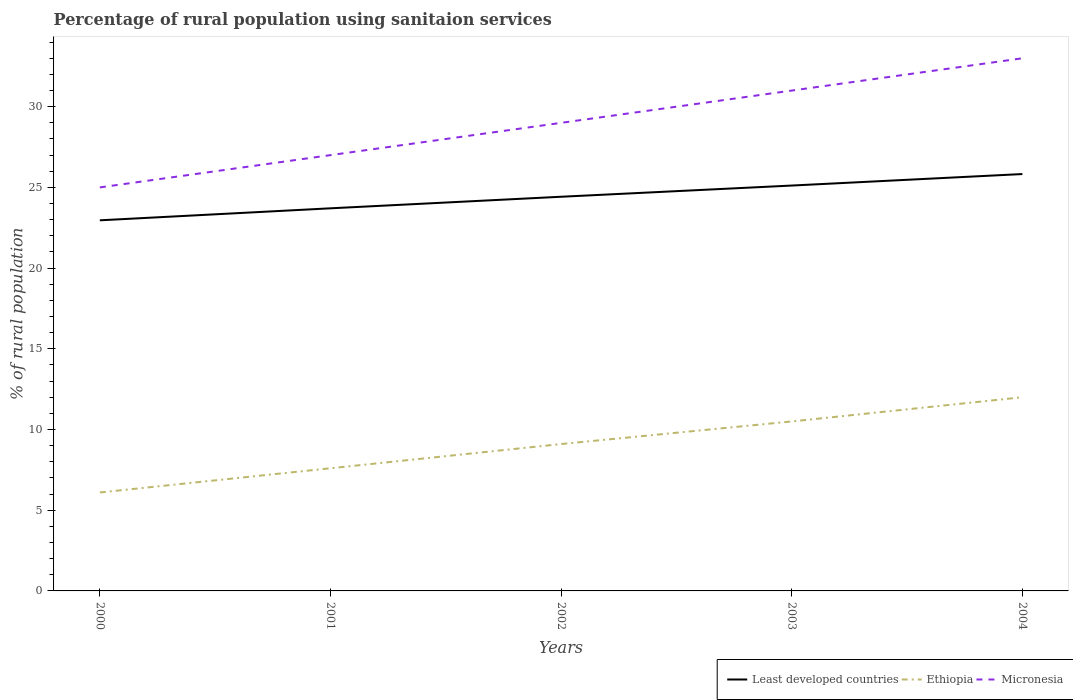Does the line corresponding to Least developed countries intersect with the line corresponding to Micronesia?
Give a very brief answer. No. Across all years, what is the maximum percentage of rural population using sanitaion services in Least developed countries?
Your response must be concise. 22.96. In which year was the percentage of rural population using sanitaion services in Ethiopia maximum?
Offer a very short reply. 2000. What is the total percentage of rural population using sanitaion services in Micronesia in the graph?
Ensure brevity in your answer.  -8. What is the difference between the highest and the second highest percentage of rural population using sanitaion services in Micronesia?
Ensure brevity in your answer.  8. What is the difference between the highest and the lowest percentage of rural population using sanitaion services in Ethiopia?
Give a very brief answer. 3. How many lines are there?
Your answer should be very brief. 3. Are the values on the major ticks of Y-axis written in scientific E-notation?
Make the answer very short. No. Does the graph contain grids?
Give a very brief answer. No. How are the legend labels stacked?
Your answer should be very brief. Horizontal. What is the title of the graph?
Make the answer very short. Percentage of rural population using sanitaion services. What is the label or title of the Y-axis?
Keep it short and to the point. % of rural population. What is the % of rural population in Least developed countries in 2000?
Give a very brief answer. 22.96. What is the % of rural population of Ethiopia in 2000?
Give a very brief answer. 6.1. What is the % of rural population of Micronesia in 2000?
Ensure brevity in your answer.  25. What is the % of rural population in Least developed countries in 2001?
Offer a very short reply. 23.7. What is the % of rural population of Ethiopia in 2001?
Your answer should be compact. 7.6. What is the % of rural population in Least developed countries in 2002?
Offer a terse response. 24.42. What is the % of rural population of Ethiopia in 2002?
Offer a very short reply. 9.1. What is the % of rural population in Least developed countries in 2003?
Provide a short and direct response. 25.12. What is the % of rural population of Ethiopia in 2003?
Your answer should be compact. 10.5. What is the % of rural population of Least developed countries in 2004?
Offer a very short reply. 25.83. What is the % of rural population in Micronesia in 2004?
Your response must be concise. 33. Across all years, what is the maximum % of rural population of Least developed countries?
Offer a very short reply. 25.83. Across all years, what is the minimum % of rural population in Least developed countries?
Offer a terse response. 22.96. Across all years, what is the minimum % of rural population in Ethiopia?
Your response must be concise. 6.1. What is the total % of rural population in Least developed countries in the graph?
Your answer should be compact. 122.03. What is the total % of rural population of Ethiopia in the graph?
Offer a very short reply. 45.3. What is the total % of rural population in Micronesia in the graph?
Give a very brief answer. 145. What is the difference between the % of rural population of Least developed countries in 2000 and that in 2001?
Offer a terse response. -0.74. What is the difference between the % of rural population in Ethiopia in 2000 and that in 2001?
Make the answer very short. -1.5. What is the difference between the % of rural population in Least developed countries in 2000 and that in 2002?
Ensure brevity in your answer.  -1.46. What is the difference between the % of rural population in Least developed countries in 2000 and that in 2003?
Your answer should be very brief. -2.15. What is the difference between the % of rural population of Least developed countries in 2000 and that in 2004?
Offer a terse response. -2.87. What is the difference between the % of rural population of Least developed countries in 2001 and that in 2002?
Give a very brief answer. -0.72. What is the difference between the % of rural population in Ethiopia in 2001 and that in 2002?
Offer a very short reply. -1.5. What is the difference between the % of rural population of Micronesia in 2001 and that in 2002?
Give a very brief answer. -2. What is the difference between the % of rural population in Least developed countries in 2001 and that in 2003?
Offer a terse response. -1.41. What is the difference between the % of rural population of Ethiopia in 2001 and that in 2003?
Your response must be concise. -2.9. What is the difference between the % of rural population of Least developed countries in 2001 and that in 2004?
Your response must be concise. -2.12. What is the difference between the % of rural population of Least developed countries in 2002 and that in 2003?
Offer a very short reply. -0.69. What is the difference between the % of rural population of Micronesia in 2002 and that in 2003?
Offer a very short reply. -2. What is the difference between the % of rural population of Least developed countries in 2002 and that in 2004?
Ensure brevity in your answer.  -1.41. What is the difference between the % of rural population in Micronesia in 2002 and that in 2004?
Your answer should be compact. -4. What is the difference between the % of rural population in Least developed countries in 2003 and that in 2004?
Offer a very short reply. -0.71. What is the difference between the % of rural population in Ethiopia in 2003 and that in 2004?
Your response must be concise. -1.5. What is the difference between the % of rural population in Least developed countries in 2000 and the % of rural population in Ethiopia in 2001?
Make the answer very short. 15.36. What is the difference between the % of rural population in Least developed countries in 2000 and the % of rural population in Micronesia in 2001?
Keep it short and to the point. -4.04. What is the difference between the % of rural population in Ethiopia in 2000 and the % of rural population in Micronesia in 2001?
Your response must be concise. -20.9. What is the difference between the % of rural population of Least developed countries in 2000 and the % of rural population of Ethiopia in 2002?
Give a very brief answer. 13.86. What is the difference between the % of rural population of Least developed countries in 2000 and the % of rural population of Micronesia in 2002?
Offer a very short reply. -6.04. What is the difference between the % of rural population in Ethiopia in 2000 and the % of rural population in Micronesia in 2002?
Your response must be concise. -22.9. What is the difference between the % of rural population of Least developed countries in 2000 and the % of rural population of Ethiopia in 2003?
Provide a short and direct response. 12.46. What is the difference between the % of rural population in Least developed countries in 2000 and the % of rural population in Micronesia in 2003?
Your response must be concise. -8.04. What is the difference between the % of rural population of Ethiopia in 2000 and the % of rural population of Micronesia in 2003?
Ensure brevity in your answer.  -24.9. What is the difference between the % of rural population of Least developed countries in 2000 and the % of rural population of Ethiopia in 2004?
Your answer should be compact. 10.96. What is the difference between the % of rural population of Least developed countries in 2000 and the % of rural population of Micronesia in 2004?
Provide a succinct answer. -10.04. What is the difference between the % of rural population in Ethiopia in 2000 and the % of rural population in Micronesia in 2004?
Offer a terse response. -26.9. What is the difference between the % of rural population of Least developed countries in 2001 and the % of rural population of Ethiopia in 2002?
Provide a short and direct response. 14.6. What is the difference between the % of rural population of Least developed countries in 2001 and the % of rural population of Micronesia in 2002?
Make the answer very short. -5.3. What is the difference between the % of rural population in Ethiopia in 2001 and the % of rural population in Micronesia in 2002?
Keep it short and to the point. -21.4. What is the difference between the % of rural population in Least developed countries in 2001 and the % of rural population in Ethiopia in 2003?
Provide a short and direct response. 13.2. What is the difference between the % of rural population of Least developed countries in 2001 and the % of rural population of Micronesia in 2003?
Your response must be concise. -7.3. What is the difference between the % of rural population in Ethiopia in 2001 and the % of rural population in Micronesia in 2003?
Give a very brief answer. -23.4. What is the difference between the % of rural population of Least developed countries in 2001 and the % of rural population of Ethiopia in 2004?
Ensure brevity in your answer.  11.7. What is the difference between the % of rural population of Least developed countries in 2001 and the % of rural population of Micronesia in 2004?
Ensure brevity in your answer.  -9.3. What is the difference between the % of rural population in Ethiopia in 2001 and the % of rural population in Micronesia in 2004?
Give a very brief answer. -25.4. What is the difference between the % of rural population of Least developed countries in 2002 and the % of rural population of Ethiopia in 2003?
Provide a succinct answer. 13.92. What is the difference between the % of rural population of Least developed countries in 2002 and the % of rural population of Micronesia in 2003?
Ensure brevity in your answer.  -6.58. What is the difference between the % of rural population in Ethiopia in 2002 and the % of rural population in Micronesia in 2003?
Your answer should be very brief. -21.9. What is the difference between the % of rural population of Least developed countries in 2002 and the % of rural population of Ethiopia in 2004?
Your answer should be compact. 12.42. What is the difference between the % of rural population in Least developed countries in 2002 and the % of rural population in Micronesia in 2004?
Make the answer very short. -8.58. What is the difference between the % of rural population in Ethiopia in 2002 and the % of rural population in Micronesia in 2004?
Provide a succinct answer. -23.9. What is the difference between the % of rural population in Least developed countries in 2003 and the % of rural population in Ethiopia in 2004?
Give a very brief answer. 13.12. What is the difference between the % of rural population of Least developed countries in 2003 and the % of rural population of Micronesia in 2004?
Provide a short and direct response. -7.88. What is the difference between the % of rural population in Ethiopia in 2003 and the % of rural population in Micronesia in 2004?
Your answer should be compact. -22.5. What is the average % of rural population of Least developed countries per year?
Provide a succinct answer. 24.41. What is the average % of rural population of Ethiopia per year?
Make the answer very short. 9.06. What is the average % of rural population in Micronesia per year?
Keep it short and to the point. 29. In the year 2000, what is the difference between the % of rural population in Least developed countries and % of rural population in Ethiopia?
Your response must be concise. 16.86. In the year 2000, what is the difference between the % of rural population of Least developed countries and % of rural population of Micronesia?
Your response must be concise. -2.04. In the year 2000, what is the difference between the % of rural population of Ethiopia and % of rural population of Micronesia?
Offer a terse response. -18.9. In the year 2001, what is the difference between the % of rural population of Least developed countries and % of rural population of Ethiopia?
Your response must be concise. 16.1. In the year 2001, what is the difference between the % of rural population of Least developed countries and % of rural population of Micronesia?
Ensure brevity in your answer.  -3.3. In the year 2001, what is the difference between the % of rural population of Ethiopia and % of rural population of Micronesia?
Ensure brevity in your answer.  -19.4. In the year 2002, what is the difference between the % of rural population of Least developed countries and % of rural population of Ethiopia?
Give a very brief answer. 15.32. In the year 2002, what is the difference between the % of rural population in Least developed countries and % of rural population in Micronesia?
Give a very brief answer. -4.58. In the year 2002, what is the difference between the % of rural population in Ethiopia and % of rural population in Micronesia?
Keep it short and to the point. -19.9. In the year 2003, what is the difference between the % of rural population of Least developed countries and % of rural population of Ethiopia?
Provide a short and direct response. 14.62. In the year 2003, what is the difference between the % of rural population of Least developed countries and % of rural population of Micronesia?
Offer a terse response. -5.88. In the year 2003, what is the difference between the % of rural population in Ethiopia and % of rural population in Micronesia?
Your answer should be very brief. -20.5. In the year 2004, what is the difference between the % of rural population of Least developed countries and % of rural population of Ethiopia?
Keep it short and to the point. 13.83. In the year 2004, what is the difference between the % of rural population in Least developed countries and % of rural population in Micronesia?
Offer a very short reply. -7.17. In the year 2004, what is the difference between the % of rural population of Ethiopia and % of rural population of Micronesia?
Provide a short and direct response. -21. What is the ratio of the % of rural population in Least developed countries in 2000 to that in 2001?
Your response must be concise. 0.97. What is the ratio of the % of rural population of Ethiopia in 2000 to that in 2001?
Give a very brief answer. 0.8. What is the ratio of the % of rural population in Micronesia in 2000 to that in 2001?
Make the answer very short. 0.93. What is the ratio of the % of rural population of Least developed countries in 2000 to that in 2002?
Keep it short and to the point. 0.94. What is the ratio of the % of rural population in Ethiopia in 2000 to that in 2002?
Ensure brevity in your answer.  0.67. What is the ratio of the % of rural population of Micronesia in 2000 to that in 2002?
Provide a succinct answer. 0.86. What is the ratio of the % of rural population of Least developed countries in 2000 to that in 2003?
Offer a very short reply. 0.91. What is the ratio of the % of rural population in Ethiopia in 2000 to that in 2003?
Offer a very short reply. 0.58. What is the ratio of the % of rural population in Micronesia in 2000 to that in 2003?
Provide a succinct answer. 0.81. What is the ratio of the % of rural population in Least developed countries in 2000 to that in 2004?
Your response must be concise. 0.89. What is the ratio of the % of rural population in Ethiopia in 2000 to that in 2004?
Ensure brevity in your answer.  0.51. What is the ratio of the % of rural population of Micronesia in 2000 to that in 2004?
Your answer should be compact. 0.76. What is the ratio of the % of rural population in Least developed countries in 2001 to that in 2002?
Provide a short and direct response. 0.97. What is the ratio of the % of rural population of Ethiopia in 2001 to that in 2002?
Ensure brevity in your answer.  0.84. What is the ratio of the % of rural population in Micronesia in 2001 to that in 2002?
Ensure brevity in your answer.  0.93. What is the ratio of the % of rural population in Least developed countries in 2001 to that in 2003?
Keep it short and to the point. 0.94. What is the ratio of the % of rural population of Ethiopia in 2001 to that in 2003?
Provide a short and direct response. 0.72. What is the ratio of the % of rural population in Micronesia in 2001 to that in 2003?
Keep it short and to the point. 0.87. What is the ratio of the % of rural population in Least developed countries in 2001 to that in 2004?
Make the answer very short. 0.92. What is the ratio of the % of rural population in Ethiopia in 2001 to that in 2004?
Ensure brevity in your answer.  0.63. What is the ratio of the % of rural population in Micronesia in 2001 to that in 2004?
Provide a short and direct response. 0.82. What is the ratio of the % of rural population of Least developed countries in 2002 to that in 2003?
Make the answer very short. 0.97. What is the ratio of the % of rural population of Ethiopia in 2002 to that in 2003?
Give a very brief answer. 0.87. What is the ratio of the % of rural population of Micronesia in 2002 to that in 2003?
Offer a very short reply. 0.94. What is the ratio of the % of rural population of Least developed countries in 2002 to that in 2004?
Ensure brevity in your answer.  0.95. What is the ratio of the % of rural population of Ethiopia in 2002 to that in 2004?
Your answer should be very brief. 0.76. What is the ratio of the % of rural population of Micronesia in 2002 to that in 2004?
Provide a short and direct response. 0.88. What is the ratio of the % of rural population of Least developed countries in 2003 to that in 2004?
Ensure brevity in your answer.  0.97. What is the ratio of the % of rural population in Ethiopia in 2003 to that in 2004?
Your response must be concise. 0.88. What is the ratio of the % of rural population of Micronesia in 2003 to that in 2004?
Provide a succinct answer. 0.94. What is the difference between the highest and the second highest % of rural population of Least developed countries?
Ensure brevity in your answer.  0.71. What is the difference between the highest and the second highest % of rural population in Ethiopia?
Your answer should be very brief. 1.5. What is the difference between the highest and the second highest % of rural population in Micronesia?
Your response must be concise. 2. What is the difference between the highest and the lowest % of rural population in Least developed countries?
Keep it short and to the point. 2.87. 